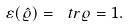<formula> <loc_0><loc_0><loc_500><loc_500>\varepsilon ( \hat { \varrho } ) = \ t r \varrho = 1 .</formula> 